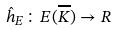Convert formula to latex. <formula><loc_0><loc_0><loc_500><loc_500>\hat { h } _ { E } \colon E ( \overline { K } ) \rightarrow R</formula> 